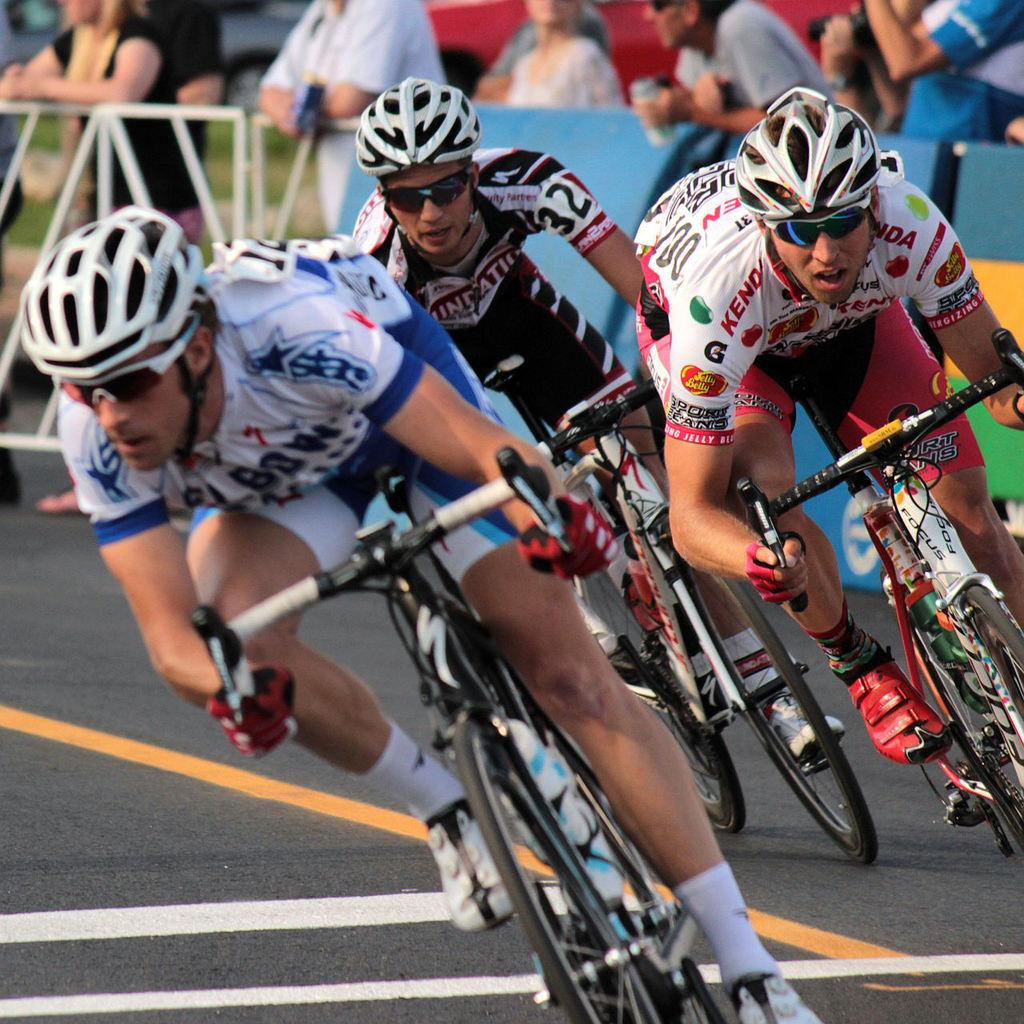How many people are in the image? There are three people in the image. What are the three people doing in the image? The three people are riding a bicycle. What can be seen in the background of the image? There is a crowd visible in the background of the image. Can you see the ocean in the image? No, the ocean is not present in the image. Is the scene taking place in a room? No, the image does not depict a room; it shows three people riding a bicycle outdoors. 